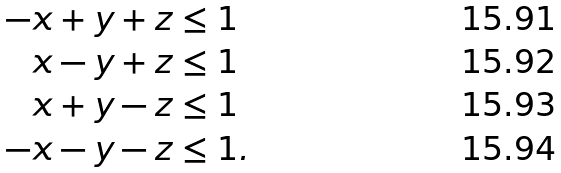<formula> <loc_0><loc_0><loc_500><loc_500>- x + y + z & \leq 1 \\ x - y + z & \leq 1 \\ x + y - z & \leq 1 \\ - x - y - z & \leq 1 .</formula> 